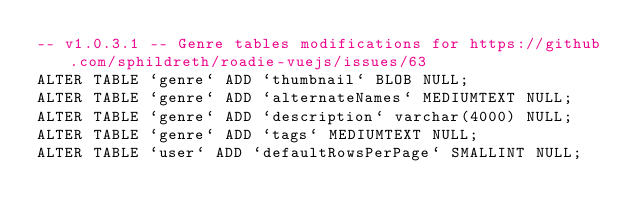<code> <loc_0><loc_0><loc_500><loc_500><_SQL_>-- v1.0.3.1 -- Genre tables modifications for https://github.com/sphildreth/roadie-vuejs/issues/63
ALTER TABLE `genre` ADD `thumbnail` BLOB NULL;
ALTER TABLE `genre` ADD `alternateNames` MEDIUMTEXT NULL;
ALTER TABLE `genre` ADD `description` varchar(4000) NULL;
ALTER TABLE `genre` ADD `tags` MEDIUMTEXT NULL;
ALTER TABLE `user` ADD `defaultRowsPerPage` SMALLINT NULL;</code> 